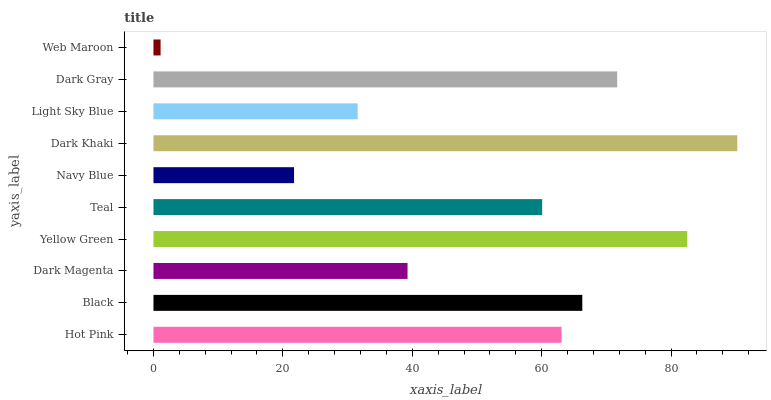Is Web Maroon the minimum?
Answer yes or no. Yes. Is Dark Khaki the maximum?
Answer yes or no. Yes. Is Black the minimum?
Answer yes or no. No. Is Black the maximum?
Answer yes or no. No. Is Black greater than Hot Pink?
Answer yes or no. Yes. Is Hot Pink less than Black?
Answer yes or no. Yes. Is Hot Pink greater than Black?
Answer yes or no. No. Is Black less than Hot Pink?
Answer yes or no. No. Is Hot Pink the high median?
Answer yes or no. Yes. Is Teal the low median?
Answer yes or no. Yes. Is Black the high median?
Answer yes or no. No. Is Dark Magenta the low median?
Answer yes or no. No. 